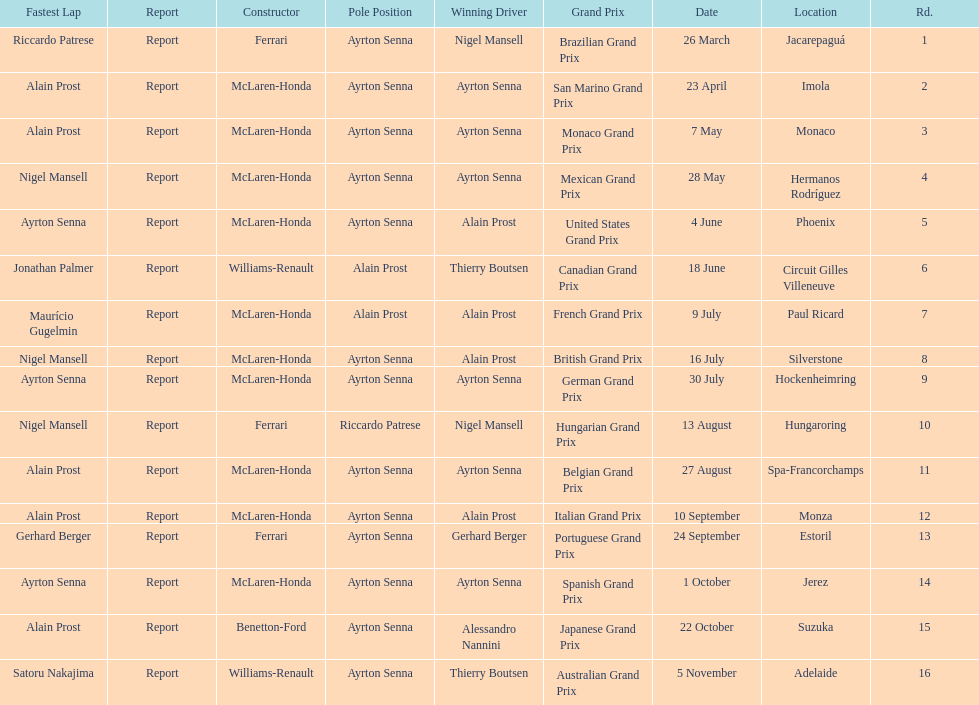Who are the constructors in the 1989 formula one season? Ferrari, McLaren-Honda, McLaren-Honda, McLaren-Honda, McLaren-Honda, Williams-Renault, McLaren-Honda, McLaren-Honda, McLaren-Honda, Ferrari, McLaren-Honda, McLaren-Honda, Ferrari, McLaren-Honda, Benetton-Ford, Williams-Renault. On what date was bennington ford the constructor? 22 October. What was the race on october 22? Japanese Grand Prix. 